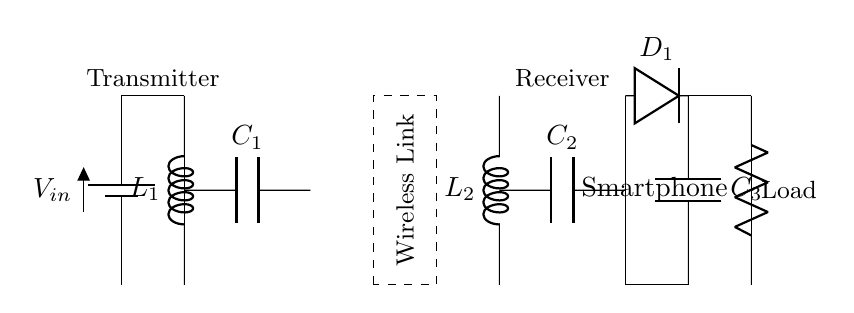What type of circuit is this? This circuit is a wireless power transfer circuit designed for smartphone charging, which includes a transmitter and receiver. The wireless link indicates the method of power transfer without direct electrical contact.
Answer: Wireless power transfer What does L1 represent? L1 represents an inductor on the transmitter side, which helps in the resonance required for efficient power transfer. It stores energy in the magnetic field when current flows through it.
Answer: Inductor What is the function of C2? C2 is a capacitor on the receiver side that works in conjunction with L2 to form an LC circuit, enabling resonance and facilitating the conversion of AC to DC for phone charging.
Answer: Capacitor How many components are in the load? The load consists of one resistor labeled as "Smartphone," which represents the device being charged.
Answer: One What is the role of D1 in the circuit? D1 is a diode that allows current to flow in one direction only, which is essential for rectifying the AC output to DC, making it suitable for charging the smartphone.
Answer: Rectification How does the wireless link affect charging efficiency? The efficiency of charging diminishes with increased distance in the wireless link, as power transfer relies on the magnetic coupling between the transmitter and receiver coils (L1 and L2).
Answer: Reduces efficiency What is the voltage input denoted as? The input voltage is denoted as V_in in the circuit, which provides power to the transmitter's inductor and capacitor arrangement.
Answer: V_in 